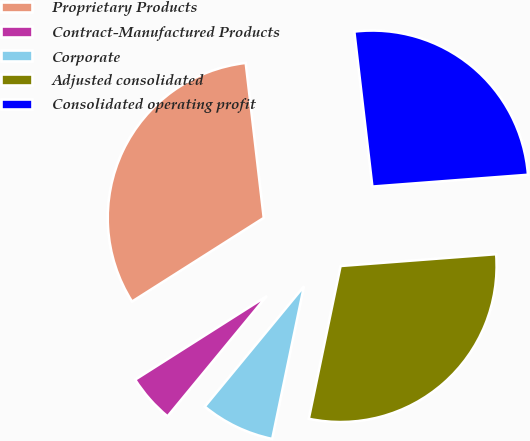<chart> <loc_0><loc_0><loc_500><loc_500><pie_chart><fcel>Proprietary Products<fcel>Contract-Manufactured Products<fcel>Corporate<fcel>Adjusted consolidated<fcel>Consolidated operating profit<nl><fcel>32.16%<fcel>5.02%<fcel>7.71%<fcel>29.47%<fcel>25.64%<nl></chart> 